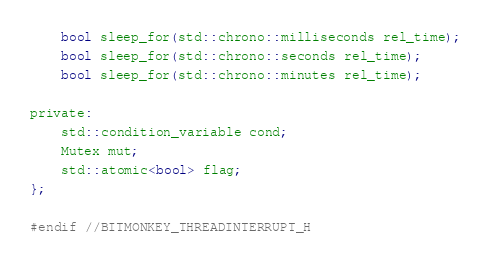Convert code to text. <code><loc_0><loc_0><loc_500><loc_500><_C_>    bool sleep_for(std::chrono::milliseconds rel_time);
    bool sleep_for(std::chrono::seconds rel_time);
    bool sleep_for(std::chrono::minutes rel_time);

private:
    std::condition_variable cond;
    Mutex mut;
    std::atomic<bool> flag;
};

#endif //BITMONKEY_THREADINTERRUPT_H
</code> 